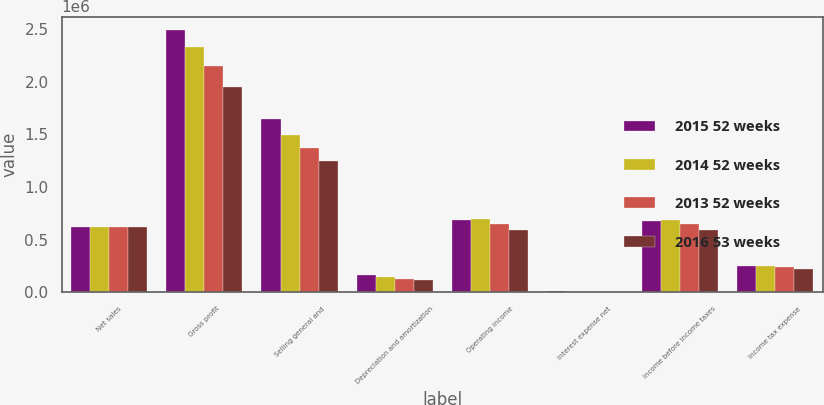Convert chart to OTSL. <chart><loc_0><loc_0><loc_500><loc_500><stacked_bar_chart><ecel><fcel>Net sales<fcel>Gross profit<fcel>Selling general and<fcel>Depreciation and amortization<fcel>Operating income<fcel>Interest expense net<fcel>Income before income taxes<fcel>Income tax expense<nl><fcel>2015 52 weeks<fcel>618544<fcel>2.49196e+06<fcel>1.63975e+06<fcel>165834<fcel>686382<fcel>13859<fcel>672523<fcel>249924<nl><fcel>2014 52 weeks<fcel>618544<fcel>2.3252e+06<fcel>1.48816e+06<fcel>142958<fcel>694080<fcel>5810<fcel>688270<fcel>251150<nl><fcel>2013 52 weeks<fcel>618544<fcel>2.14317e+06<fcel>1.3691e+06<fcel>123569<fcel>650508<fcel>2891<fcel>647617<fcel>237222<nl><fcel>2016 53 weeks<fcel>618544<fcel>1.95042e+06<fcel>1.24631e+06<fcel>114635<fcel>589472<fcel>1885<fcel>587587<fcel>216702<nl></chart> 